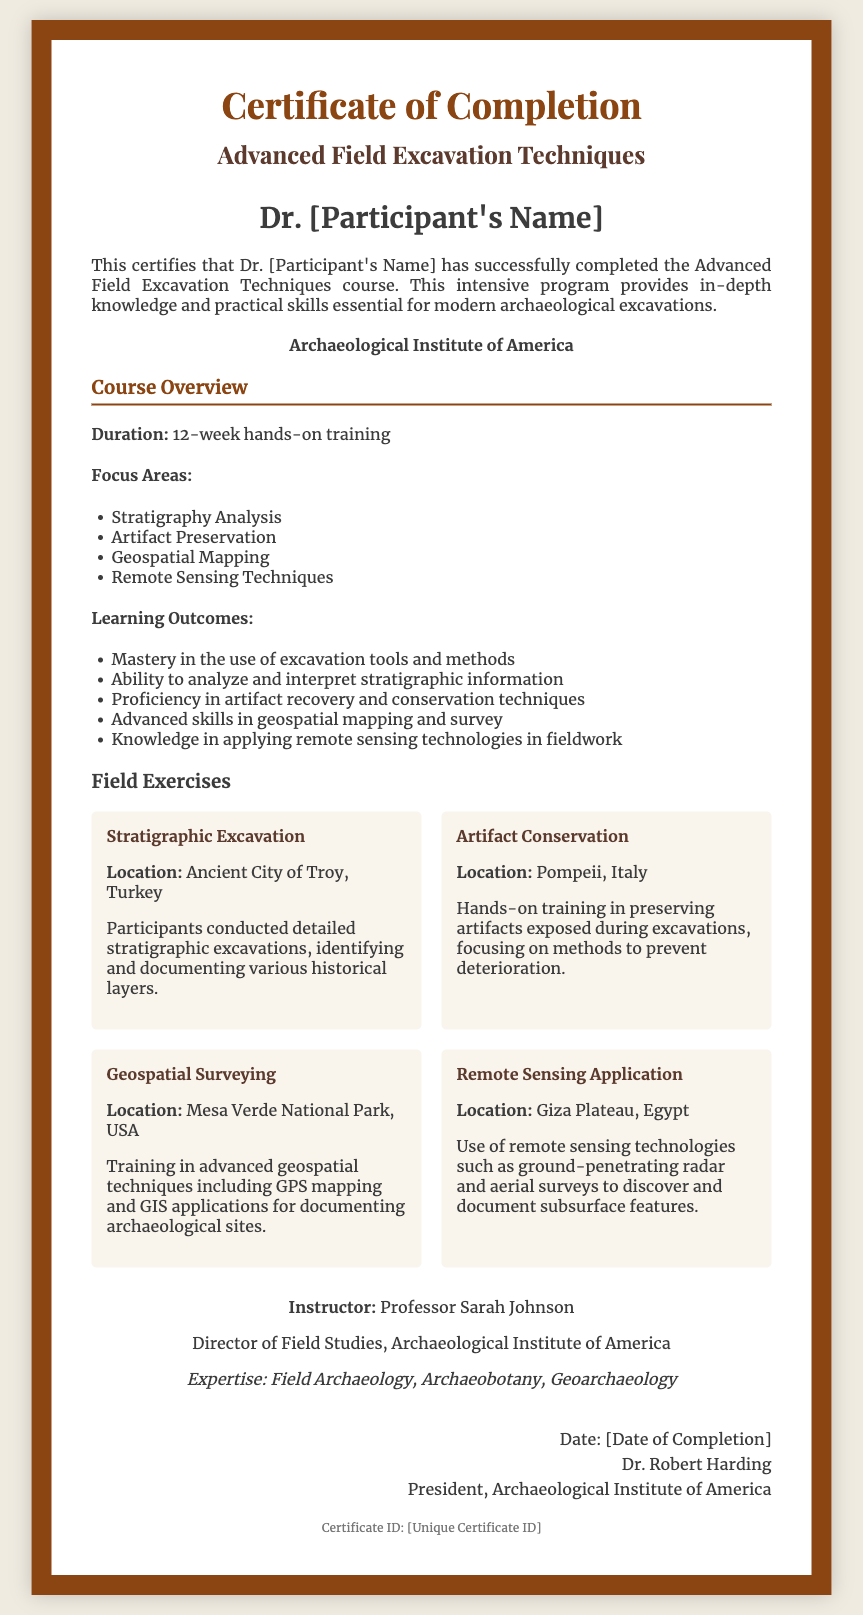What is the title of the course? The course title is explicitly stated in the document as "Advanced Field Excavation Techniques."
Answer: Advanced Field Excavation Techniques Who is the participant named in the certificate? The participant's name is mentioned prominently on the certificate, named as "Dr. [Participant's Name]."
Answer: Dr. [Participant's Name] What is the duration of the course? The duration of the course is detailed in the "Course Overview" section as "12-week hands-on training."
Answer: 12-week hands-on training Which institution issued the certificate? The issuing institution is clearly indicated in the certificate as "Archaeological Institute of America."
Answer: Archaeological Institute of America What is one focus area of the course? The course overview lists focus areas, one of which is "Stratigraphy Analysis."
Answer: Stratigraphy Analysis Who is the instructor of the course? The instructor's name is provided in the document, stated as "Professor Sarah Johnson."
Answer: Professor Sarah Johnson What is the location of the "Stratigraphic Excavation" exercise? The document specifies the location where the exercise took place as "Ancient City of Troy, Turkey."
Answer: Ancient City of Troy, Turkey What is the expertise of the course instructor? The document lists the instructor's expertise, which includes "Field Archaeology, Archaeobotany, Geoarchaeology."
Answer: Field Archaeology, Archaeobotany, Geoarchaeology What is the date format used for the completion date? The completion date is formatted as "Date: [Date of Completion]."
Answer: [Date of Completion] 